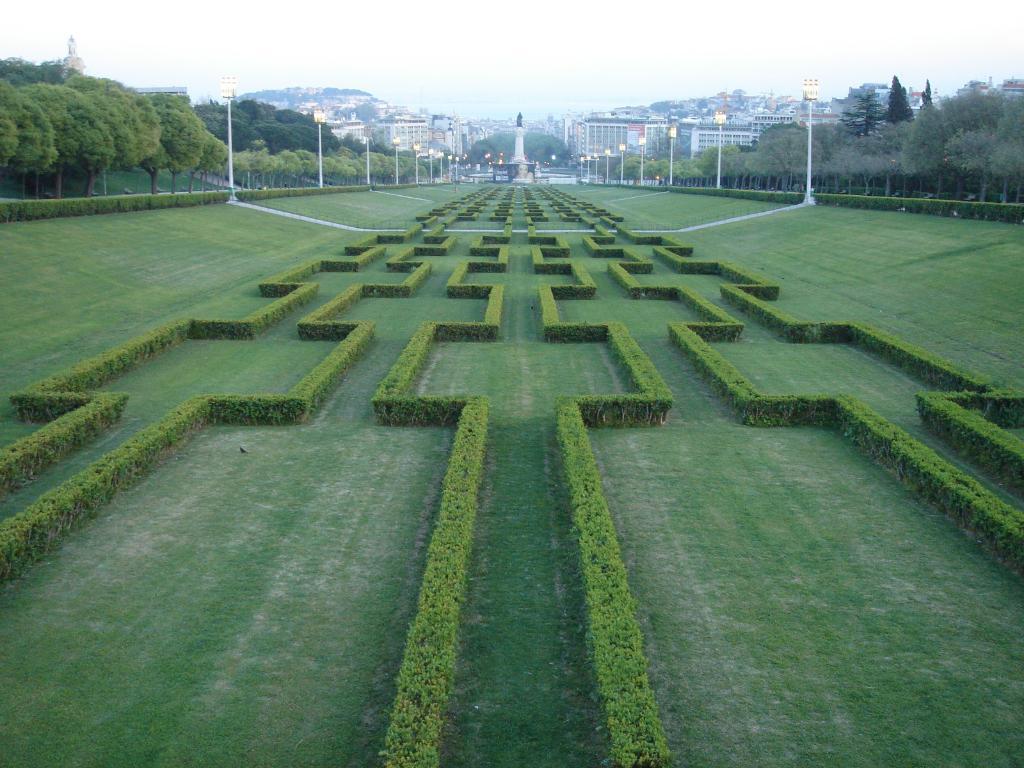Describe this image in one or two sentences. In this picture I can see there are few plants, cut into a shape and there are trees at left and right sides of the image. There are poles with lights and there are buildings in the backdrop and the sky is clear. 